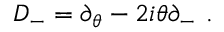Convert formula to latex. <formula><loc_0><loc_0><loc_500><loc_500>D _ { - } = \partial _ { \theta } - 2 i \theta \partial _ { - } \ .</formula> 